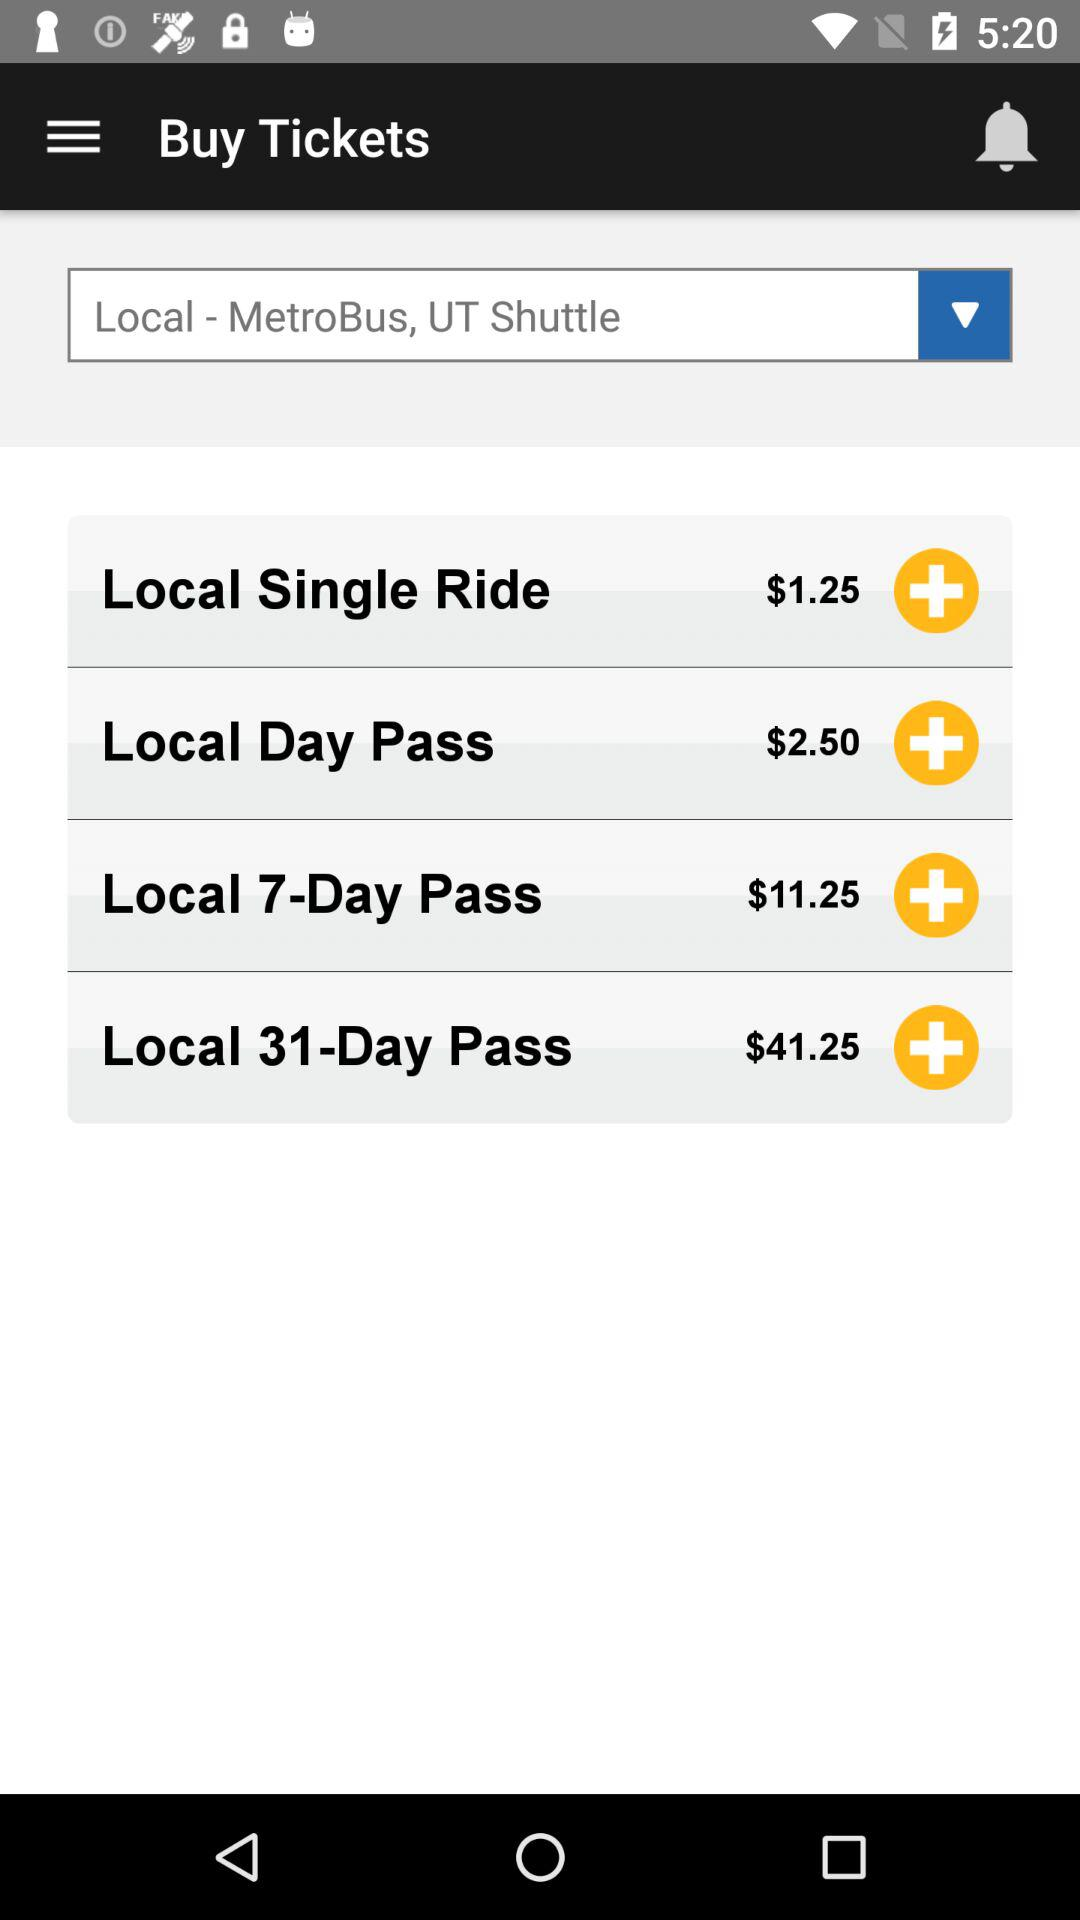What is the price of "Local Single Ride"? The price is $1.25. 